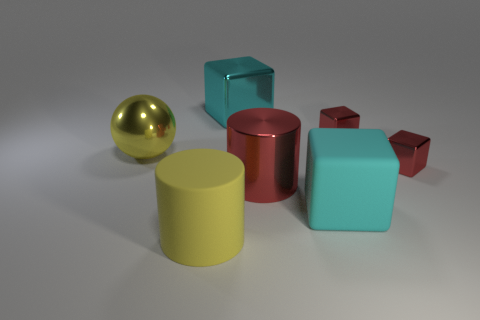Subtract all cyan blocks. How many were subtracted if there are1cyan blocks left? 1 Subtract all gray cylinders. How many red cubes are left? 2 Add 3 big cyan cubes. How many objects exist? 10 Subtract all cyan shiny cubes. How many cubes are left? 3 Subtract all balls. How many objects are left? 6 Subtract all red cubes. How many cubes are left? 2 Subtract 1 cubes. How many cubes are left? 3 Add 7 red metallic blocks. How many red metallic blocks are left? 9 Add 5 large cyan things. How many large cyan things exist? 7 Subtract 0 brown cylinders. How many objects are left? 7 